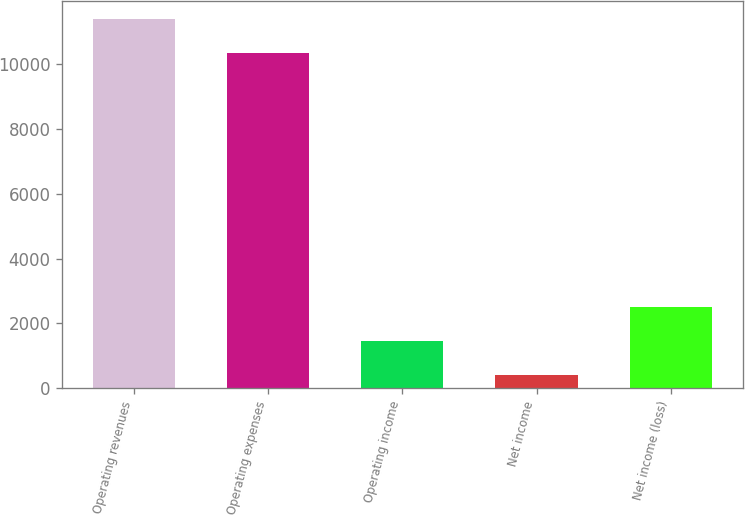Convert chart to OTSL. <chart><loc_0><loc_0><loc_500><loc_500><bar_chart><fcel>Operating revenues<fcel>Operating expenses<fcel>Operating income<fcel>Net income<fcel>Net income (loss)<nl><fcel>11396.9<fcel>10344<fcel>1459.9<fcel>407<fcel>2512.8<nl></chart> 